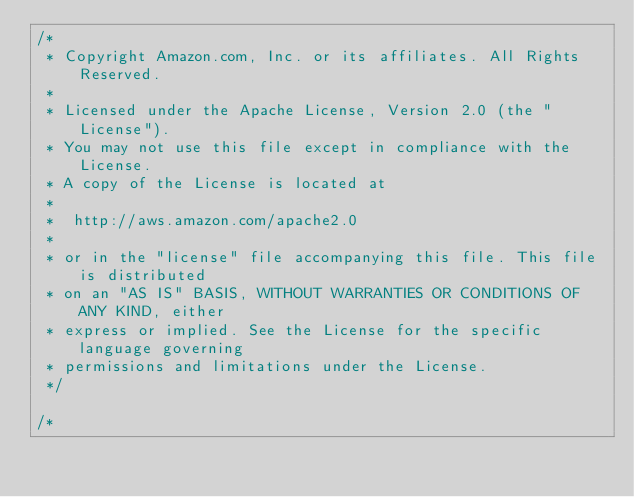Convert code to text. <code><loc_0><loc_0><loc_500><loc_500><_C#_>/*
 * Copyright Amazon.com, Inc. or its affiliates. All Rights Reserved.
 * 
 * Licensed under the Apache License, Version 2.0 (the "License").
 * You may not use this file except in compliance with the License.
 * A copy of the License is located at
 * 
 *  http://aws.amazon.com/apache2.0
 * 
 * or in the "license" file accompanying this file. This file is distributed
 * on an "AS IS" BASIS, WITHOUT WARRANTIES OR CONDITIONS OF ANY KIND, either
 * express or implied. See the License for the specific language governing
 * permissions and limitations under the License.
 */

/*</code> 